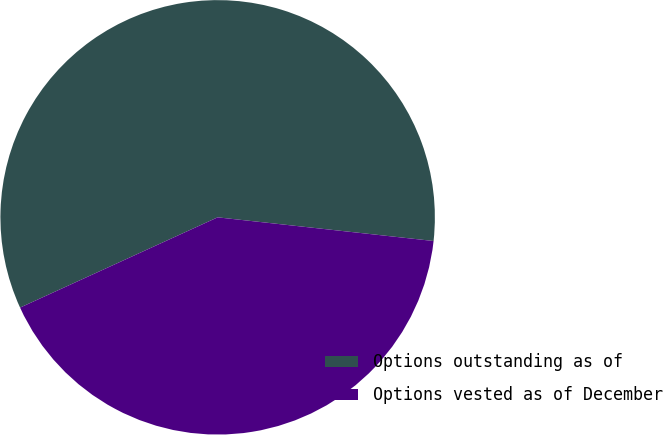<chart> <loc_0><loc_0><loc_500><loc_500><pie_chart><fcel>Options outstanding as of<fcel>Options vested as of December<nl><fcel>58.56%<fcel>41.44%<nl></chart> 